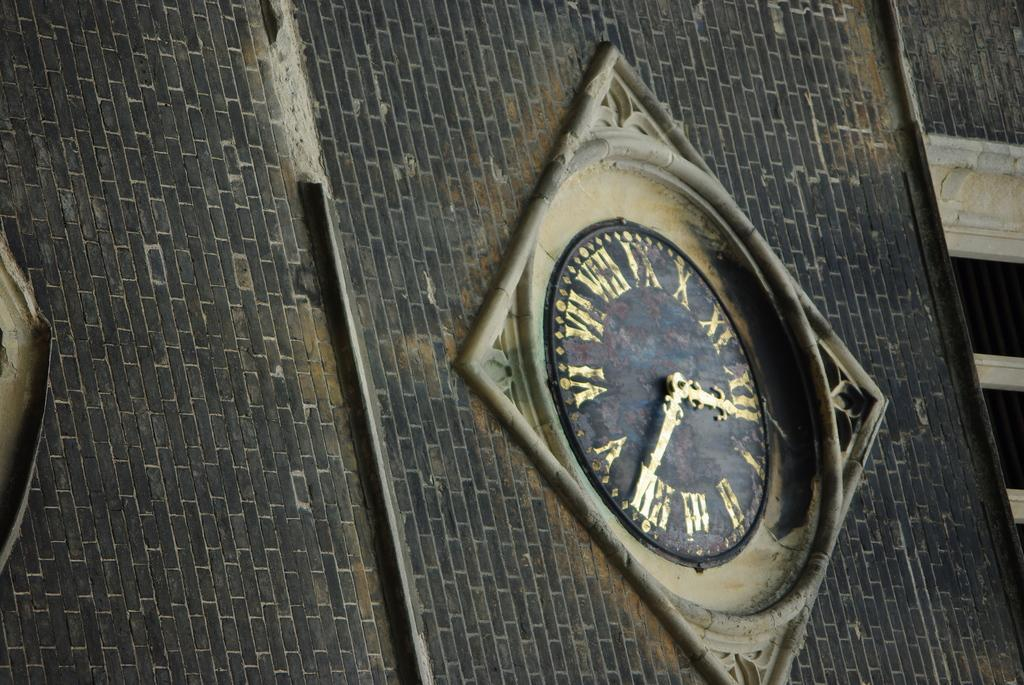What object can be seen in the image that is used for telling time? There is a clock in the image that is used for telling time. Where is the clock located in the image? The clock is on the wall in the image. What type of test is being conducted in the image? There is no test being conducted in the image; it only features a clock on the wall. 